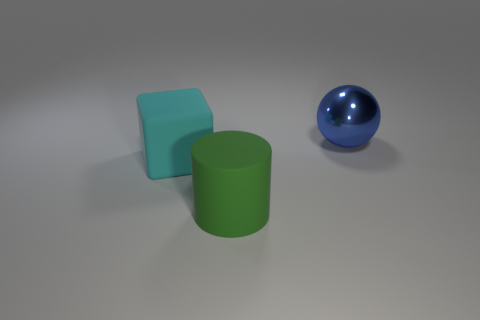What size is the cylinder that is the same material as the cyan object?
Your response must be concise. Large. The big cube that is made of the same material as the big cylinder is what color?
Ensure brevity in your answer.  Cyan. Are there any other cyan blocks of the same size as the cyan cube?
Your answer should be very brief. No. What shape is the cyan matte object that is the same size as the shiny ball?
Provide a short and direct response. Cube. Are there any other metal objects that have the same shape as the big shiny thing?
Your answer should be very brief. No. What is the shape of the thing that is to the right of the large thing in front of the big cyan thing?
Your response must be concise. Sphere. What is the shape of the big cyan rubber thing?
Ensure brevity in your answer.  Cube. What is the large object behind the large matte thing behind the large object that is in front of the cyan rubber cube made of?
Offer a terse response. Metal. How many other things are the same material as the cyan cube?
Provide a short and direct response. 1. What number of blue metal spheres are in front of the rubber object to the left of the large green rubber object?
Your answer should be compact. 0. 